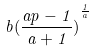Convert formula to latex. <formula><loc_0><loc_0><loc_500><loc_500>b { ( \frac { a p - 1 } { a + 1 } ) } ^ { \frac { 1 } { a } }</formula> 